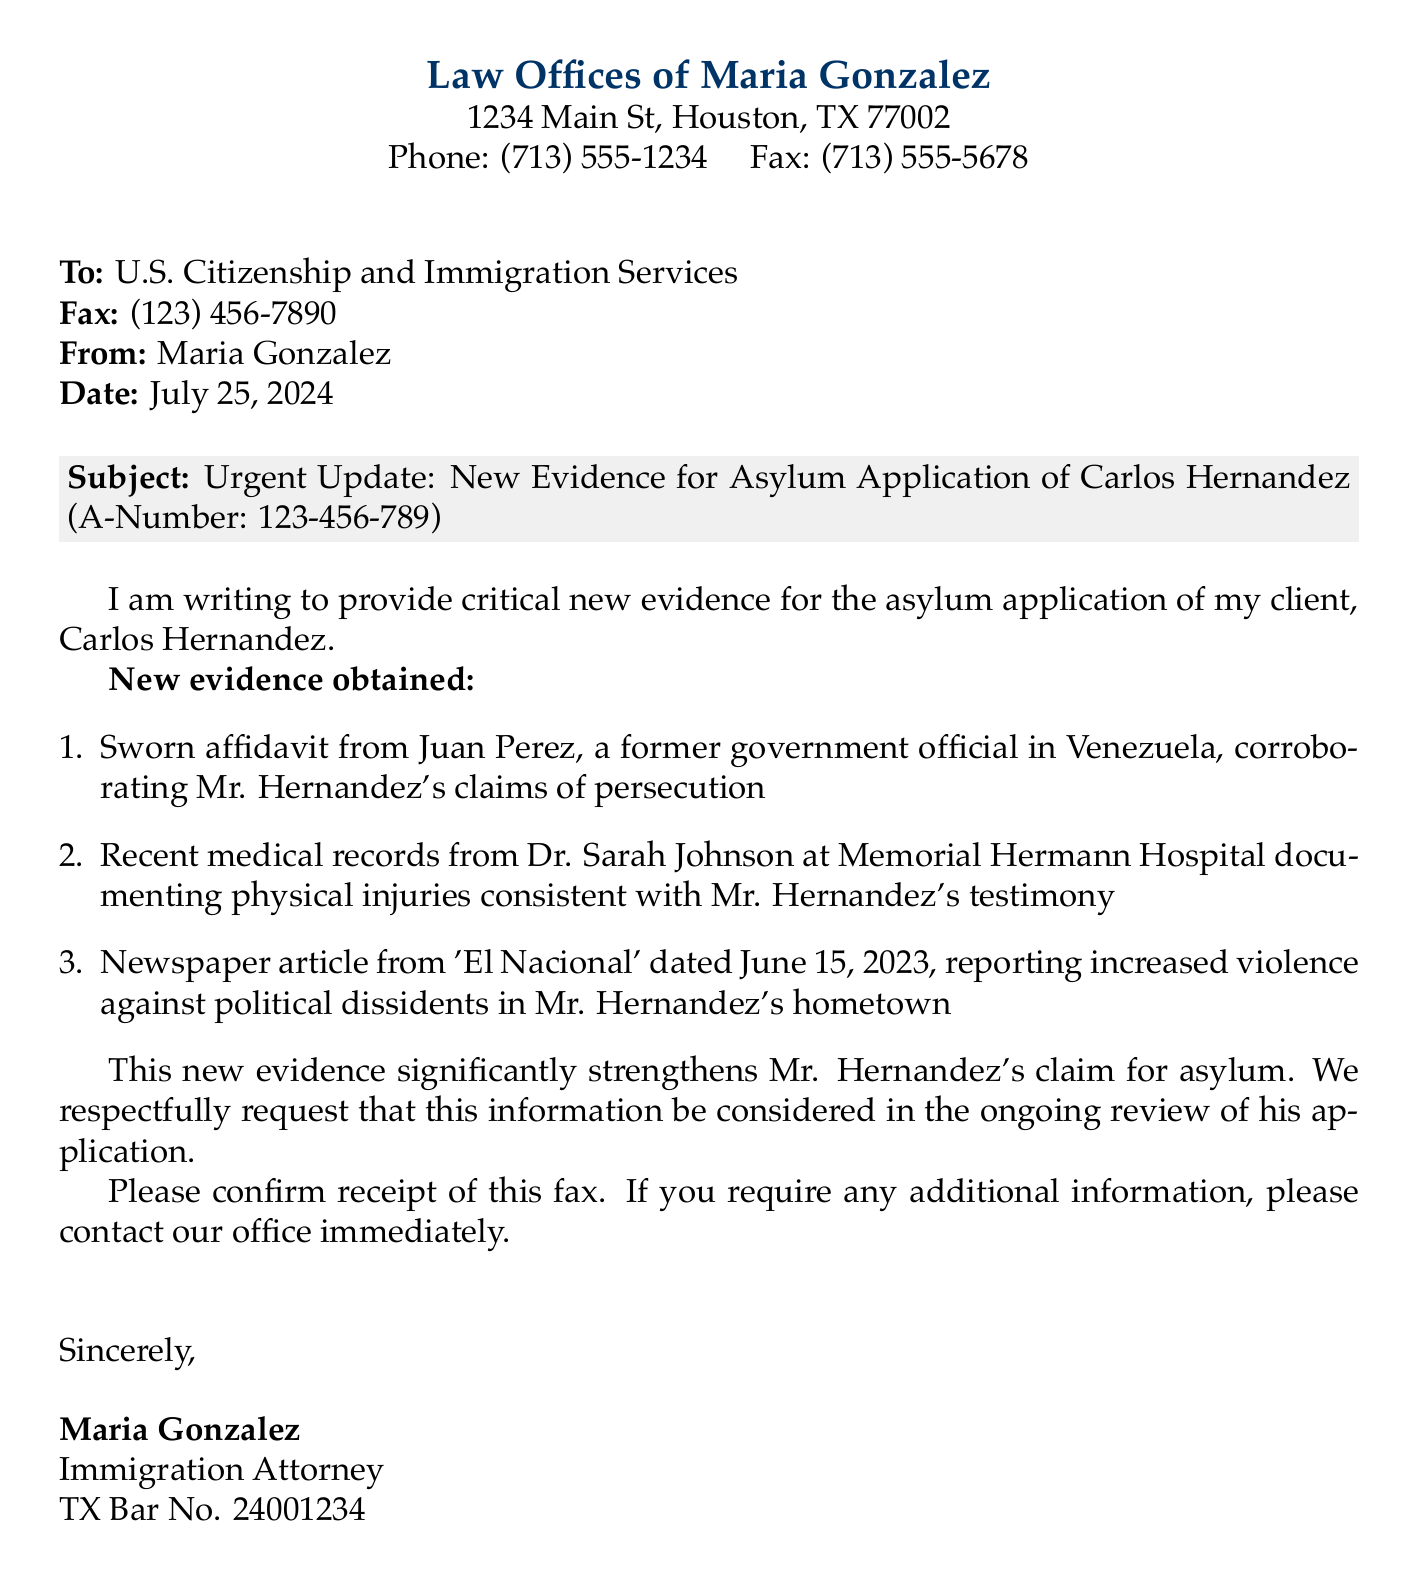What is the name of the sender? The sender's name is mentioned at the bottom of the document as Maria Gonzalez.
Answer: Maria Gonzalez What is the client's A-Number? The A-Number of the client is given in the subject line of the fax as 123-456-789.
Answer: 123-456-789 What three items of new evidence are listed? The document lists a sworn affidavit, medical records, and a newspaper article as new evidence.
Answer: Sworn affidavit, medical records, newspaper article Who provided the medical records? The medical records were provided by Dr. Sarah Johnson at Memorial Hermann Hospital.
Answer: Dr. Sarah Johnson On what date was the newspaper article published? The article date is specified in the document as June 15, 2023.
Answer: June 15, 2023 What does the fax request to the USCIS? The fax requests that the new evidence be considered in the ongoing review of the asylum application.
Answer: Consider this information What is the fax number for the U.S. Citizenship and Immigration Services? The fax number is clearly stated in the recipient section as (123) 456-7890.
Answer: (123) 456-7890 What is the significance of the new evidence according to the document? The new evidence is said to significantly strengthen Mr. Hernandez's claim for asylum.
Answer: Significantly strengthens What is the address of the law office? The address is provided at the top of the document as 1234 Main St, Houston, TX 77002.
Answer: 1234 Main St, Houston, TX 77002 What document type is this communication? The document is identified as a fax within the communication heading.
Answer: Fax 